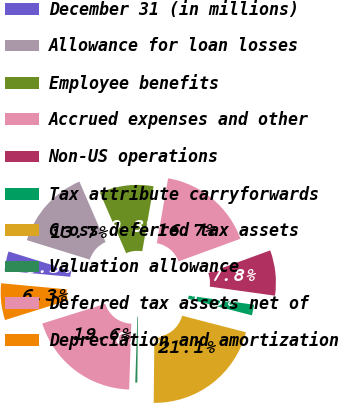Convert chart. <chart><loc_0><loc_0><loc_500><loc_500><pie_chart><fcel>December 31 (in millions)<fcel>Allowance for loan losses<fcel>Employee benefits<fcel>Accrued expenses and other<fcel>Non-US operations<fcel>Tax attribute carryforwards<fcel>Gross deferred tax assets<fcel>Valuation allowance<fcel>Deferred tax assets net of<fcel>Depreciation and amortization<nl><fcel>3.32%<fcel>13.71%<fcel>9.26%<fcel>16.68%<fcel>7.77%<fcel>1.83%<fcel>21.14%<fcel>0.35%<fcel>19.65%<fcel>6.29%<nl></chart> 